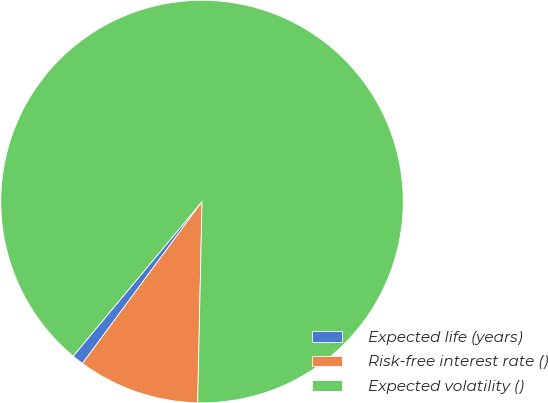Convert chart to OTSL. <chart><loc_0><loc_0><loc_500><loc_500><pie_chart><fcel>Expected life (years)<fcel>Risk-free interest rate ()<fcel>Expected volatility ()<nl><fcel>0.94%<fcel>9.78%<fcel>89.28%<nl></chart> 